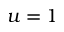Convert formula to latex. <formula><loc_0><loc_0><loc_500><loc_500>u = 1</formula> 